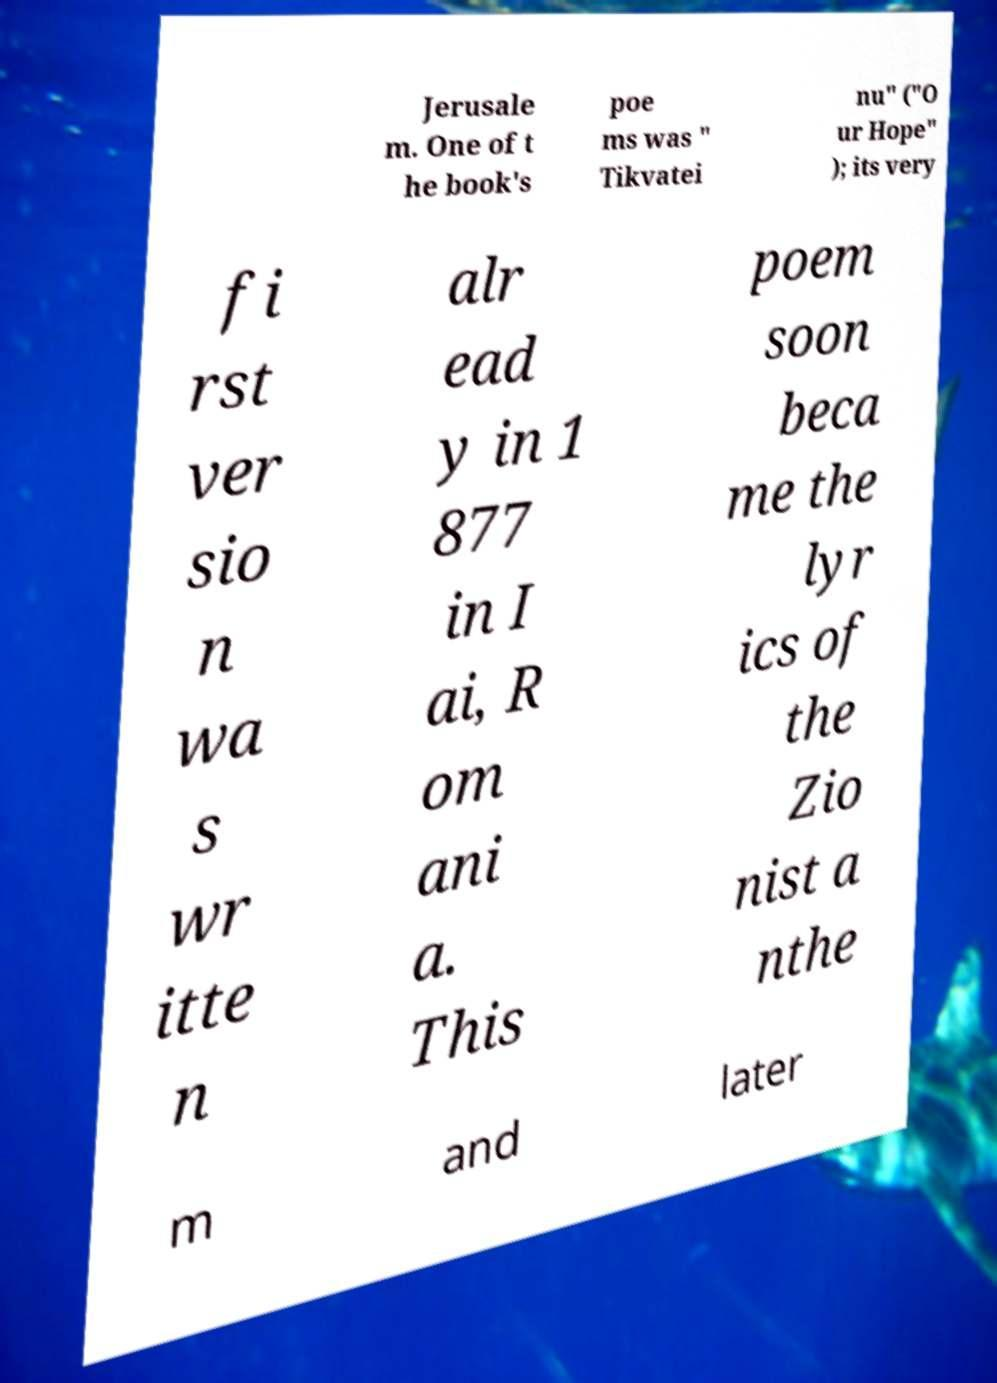I need the written content from this picture converted into text. Can you do that? Jerusale m. One of t he book's poe ms was " Tikvatei nu" ("O ur Hope" ); its very fi rst ver sio n wa s wr itte n alr ead y in 1 877 in I ai, R om ani a. This poem soon beca me the lyr ics of the Zio nist a nthe m and later 